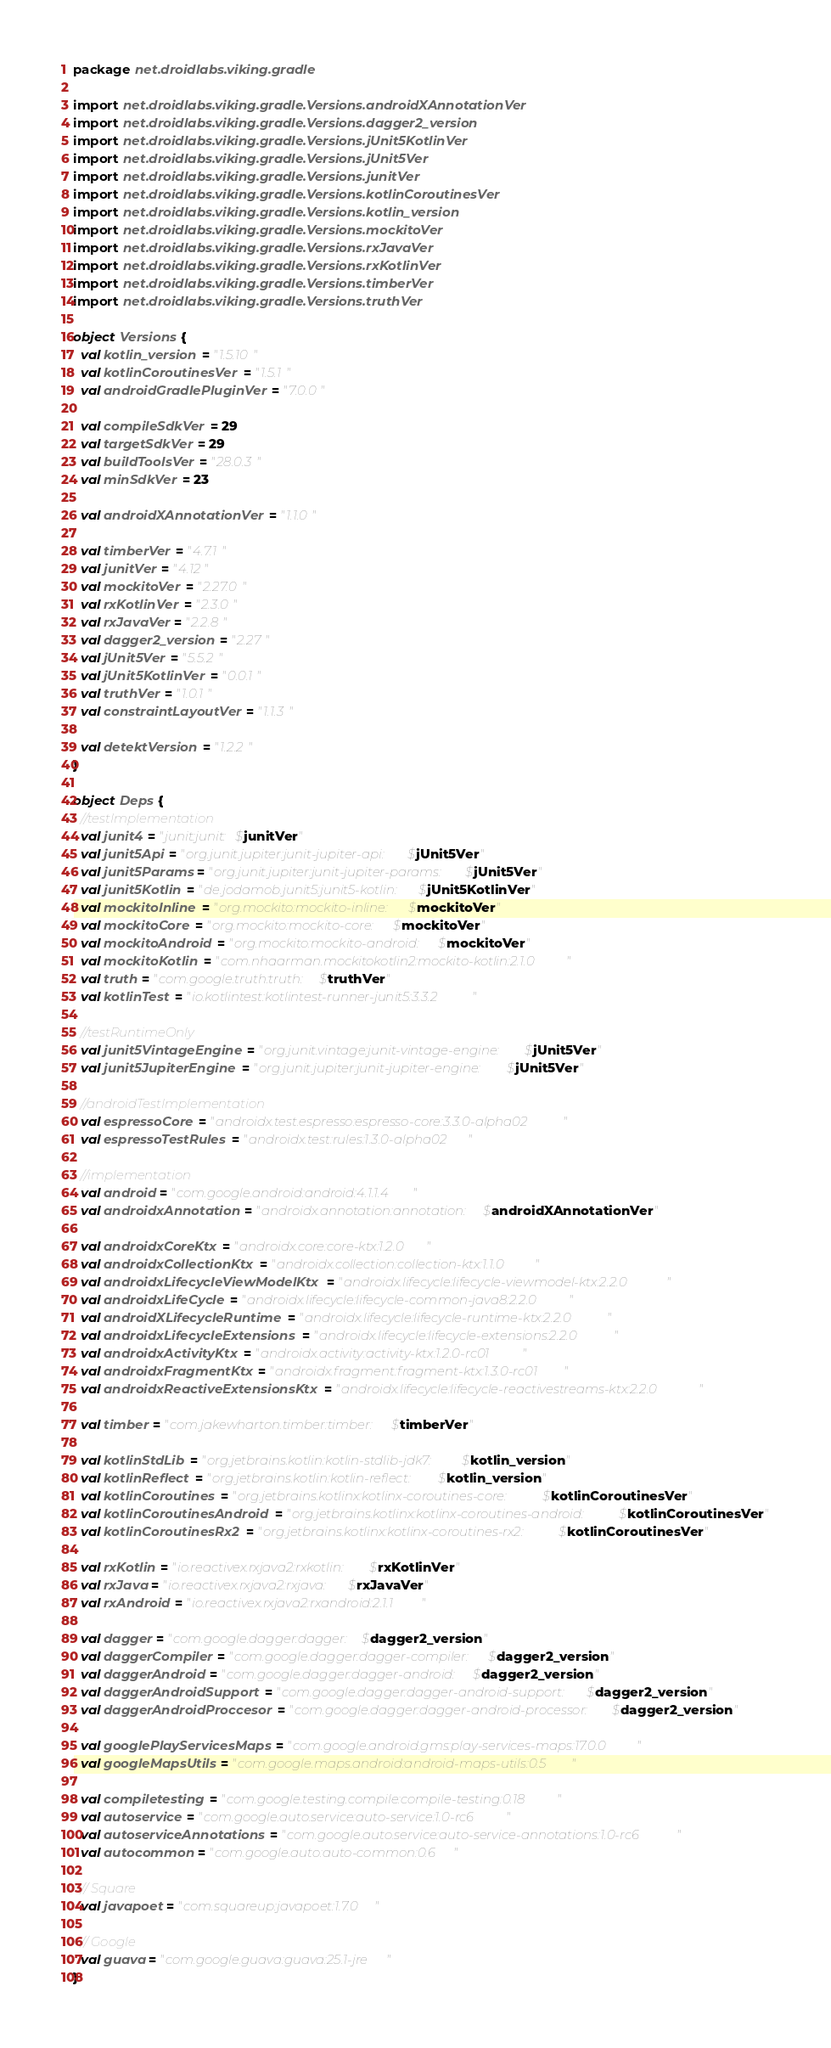Convert code to text. <code><loc_0><loc_0><loc_500><loc_500><_Kotlin_>package net.droidlabs.viking.gradle

import net.droidlabs.viking.gradle.Versions.androidXAnnotationVer
import net.droidlabs.viking.gradle.Versions.dagger2_version
import net.droidlabs.viking.gradle.Versions.jUnit5KotlinVer
import net.droidlabs.viking.gradle.Versions.jUnit5Ver
import net.droidlabs.viking.gradle.Versions.junitVer
import net.droidlabs.viking.gradle.Versions.kotlinCoroutinesVer
import net.droidlabs.viking.gradle.Versions.kotlin_version
import net.droidlabs.viking.gradle.Versions.mockitoVer
import net.droidlabs.viking.gradle.Versions.rxJavaVer
import net.droidlabs.viking.gradle.Versions.rxKotlinVer
import net.droidlabs.viking.gradle.Versions.timberVer
import net.droidlabs.viking.gradle.Versions.truthVer

object Versions {
  val kotlin_version = "1.5.10"
  val kotlinCoroutinesVer = "1.5.1"
  val androidGradlePluginVer = "7.0.0"

  val compileSdkVer = 29
  val targetSdkVer = 29
  val buildToolsVer = "28.0.3"
  val minSdkVer = 23

  val androidXAnnotationVer = "1.1.0"

  val timberVer = "4.7.1"
  val junitVer = "4.12"
  val mockitoVer = "2.27.0"
  val rxKotlinVer = "2.3.0"
  val rxJavaVer = "2.2.8"
  val dagger2_version = "2.27"
  val jUnit5Ver = "5.5.2"
  val jUnit5KotlinVer = "0.0.1"
  val truthVer = "1.0.1"
  val constraintLayoutVer = "1.1.3"

  val detektVersion = "1.2.2"
}

object Deps {
  //testImplementation
  val junit4 = "junit:junit:$junitVer"
  val junit5Api = "org.junit.jupiter:junit-jupiter-api:$jUnit5Ver"
  val junit5Params = "org.junit.jupiter:junit-jupiter-params:$jUnit5Ver"
  val junit5Kotlin = "de.jodamob.junit5:junit5-kotlin:$jUnit5KotlinVer"
  val mockitoInline = "org.mockito:mockito-inline:$mockitoVer"
  val mockitoCore = "org.mockito:mockito-core:$mockitoVer"
  val mockitoAndroid = "org.mockito:mockito-android:$mockitoVer"
  val mockitoKotlin = "com.nhaarman.mockitokotlin2:mockito-kotlin:2.1.0"
  val truth = "com.google.truth:truth:$truthVer"
  val kotlinTest = "io.kotlintest:kotlintest-runner-junit5:3.3.2"

  //testRuntimeOnly
  val junit5VintageEngine = "org.junit.vintage:junit-vintage-engine:$jUnit5Ver"
  val junit5JupiterEngine = "org.junit.jupiter:junit-jupiter-engine:$jUnit5Ver"

  //androidTestImplementation
  val espressoCore = "androidx.test.espresso:espresso-core:3.3.0-alpha02"
  val espressoTestRules = "androidx.test:rules:1.3.0-alpha02"

  //implementation
  val android = "com.google.android:android:4.1.1.4"
  val androidxAnnotation = "androidx.annotation:annotation:$androidXAnnotationVer"

  val androidxCoreKtx = "androidx.core:core-ktx:1.2.0"
  val androidxCollectionKtx = "androidx.collection:collection-ktx:1.1.0"
  val androidxLifecycleViewModelKtx = "androidx.lifecycle:lifecycle-viewmodel-ktx:2.2.0"
  val androidxLifeCycle = "androidx.lifecycle:lifecycle-common-java8:2.2.0"
  val androidXLifecycleRuntime = "androidx.lifecycle:lifecycle-runtime-ktx:2.2.0"
  val androidxLifecycleExtensions = "androidx.lifecycle:lifecycle-extensions:2.2.0"
  val androidxActivityKtx = "androidx.activity:activity-ktx:1.2.0-rc01"
  val androidxFragmentKtx = "androidx.fragment:fragment-ktx:1.3.0-rc01"
  val androidxReactiveExtensionsKtx = "androidx.lifecycle:lifecycle-reactivestreams-ktx:2.2.0"

  val timber = "com.jakewharton.timber:timber:$timberVer"

  val kotlinStdLib = "org.jetbrains.kotlin:kotlin-stdlib-jdk7:$kotlin_version"
  val kotlinReflect = "org.jetbrains.kotlin:kotlin-reflect:$kotlin_version"
  val kotlinCoroutines = "org.jetbrains.kotlinx:kotlinx-coroutines-core:$kotlinCoroutinesVer"
  val kotlinCoroutinesAndroid = "org.jetbrains.kotlinx:kotlinx-coroutines-android:$kotlinCoroutinesVer"
  val kotlinCoroutinesRx2 = "org.jetbrains.kotlinx:kotlinx-coroutines-rx2:$kotlinCoroutinesVer"

  val rxKotlin = "io.reactivex.rxjava2:rxkotlin:$rxKotlinVer"
  val rxJava = "io.reactivex.rxjava2:rxjava:$rxJavaVer"
  val rxAndroid = "io.reactivex.rxjava2:rxandroid:2.1.1"

  val dagger = "com.google.dagger:dagger:$dagger2_version"
  val daggerCompiler = "com.google.dagger:dagger-compiler:$dagger2_version"
  val daggerAndroid = "com.google.dagger:dagger-android:$dagger2_version"
  val daggerAndroidSupport = "com.google.dagger:dagger-android-support:$dagger2_version"
  val daggerAndroidProccesor = "com.google.dagger:dagger-android-processor:$dagger2_version"

  val googlePlayServicesMaps = "com.google.android.gms:play-services-maps:17.0.0"
  val googleMapsUtils = "com.google.maps.android:android-maps-utils:0.5"

  val compiletesting = "com.google.testing.compile:compile-testing:0.18"
  val autoservice = "com.google.auto.service:auto-service:1.0-rc6"
  val autoserviceAnnotations = "com.google.auto.service:auto-service-annotations:1.0-rc6"
  val autocommon = "com.google.auto:auto-common:0.6"

  // Square
  val javapoet = "com.squareup:javapoet:1.7.0"

  // Google
  val guava = "com.google.guava:guava:25.1-jre"
}</code> 